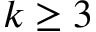<formula> <loc_0><loc_0><loc_500><loc_500>k \geq 3</formula> 